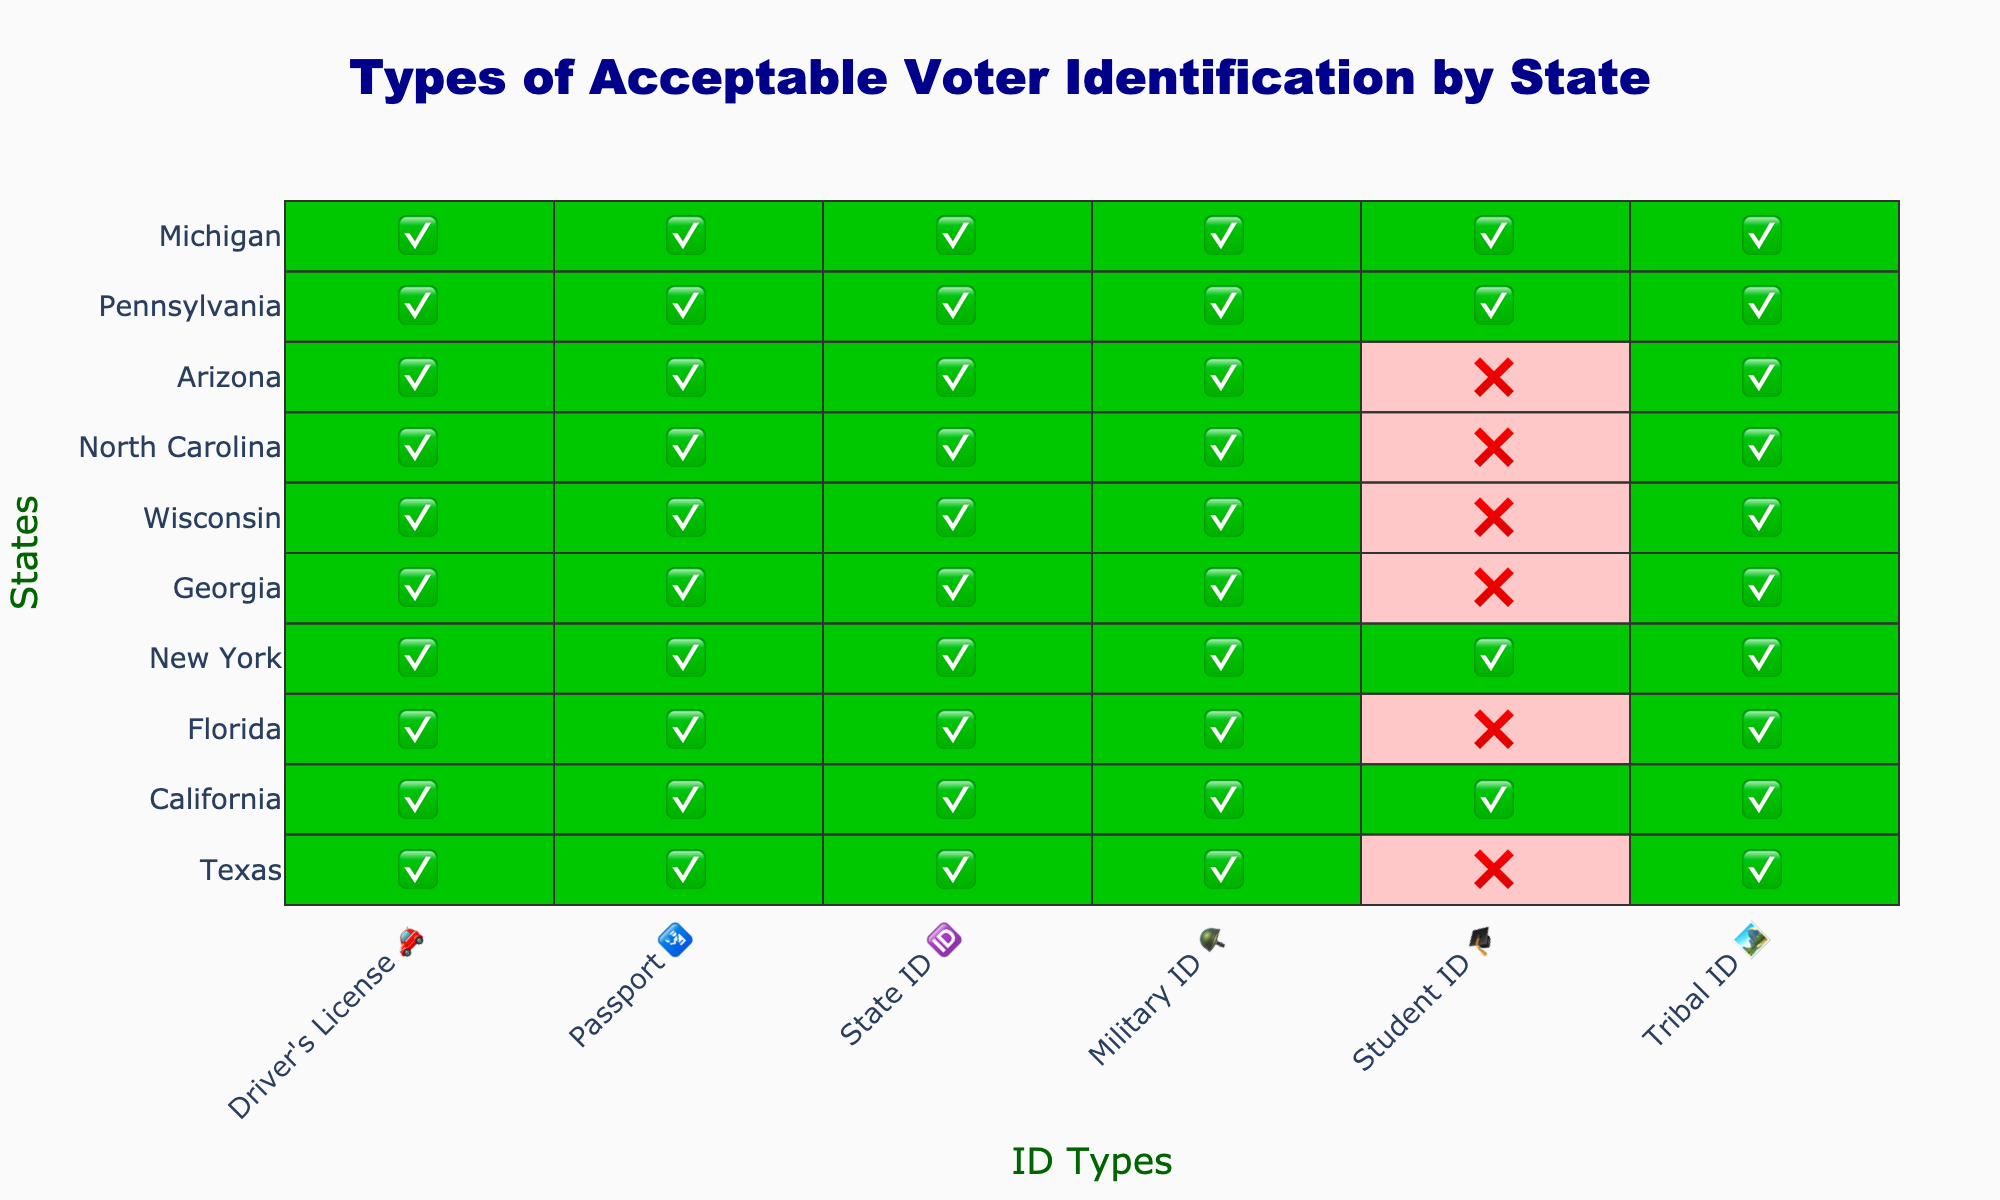Which states accept Student ID 🎓 as a valid form of voter identification? To find this, we look at the column for Student ID 🎓 and see which rows contain the checkmark emoji (✅). These rows represent the states that accept Student ID 🎓 as valid identification.
Answer: California, New York, Pennsylvania, Michigan Which ID type is accepted by all the states listed? To determine this, look for the column where every row contains a checkmark emoji (✅). This indicates that all states accept that particular ID type.
Answer: Driver's License 🚗 Which states do not accept Tribal ID 🏞️ as valid voter identification? Look at the column for Tribal ID 🏞️ and identify the rows that contain the cross emoji (❌). These rows represent the states that do not accept Tribal ID 🏞️ as valid ID.
Answer: None How many states accept Passport 🛂 as voter identification? Here, we need to count the number of checkmark emojis (✅) in the Passport 🛂 column.
Answer: 10 Which ID types are accepted by Pennsylvania? To answer this, look at the row for Pennsylvania and list all the ID types with the checkmark emoji (✅).
Answer: Driver's License 🚗, Passport 🛂, State ID 🆔, Military ID 🪖, Student ID 🎓, Tribal ID 🏞️ What's the total number of states that accept both Military ID 🪖 and State ID 🆔 as valid forms of voter identification? First, identify the states that accept Military ID 🪖 (rows with ✅ in the Military ID column). Then, among these states, find those that also have a checkmark (✅) in the State ID 🆔 column. Count these states.
Answer: 10 Which state has the most diverse acceptance of voter ID types? Examine each row to see which state has the most checkmark emojis (✅) in all ID type columns. The state with the highest number of checkmarks accepts the most diverse types of voter ID.
Answer: California, New York, Pennsylvania, Michigan (all accept 6 types) Are there any states that have the same acceptance criteria for voter identification? Compare the rows across different states to identify if there are groups of states that have the exact same pattern of checkmarks (✅) and crosses (❌) across all ID type columns.
Answer: Texas, Florida, Georgia, Wisconsin, North Carolina, Arizona 